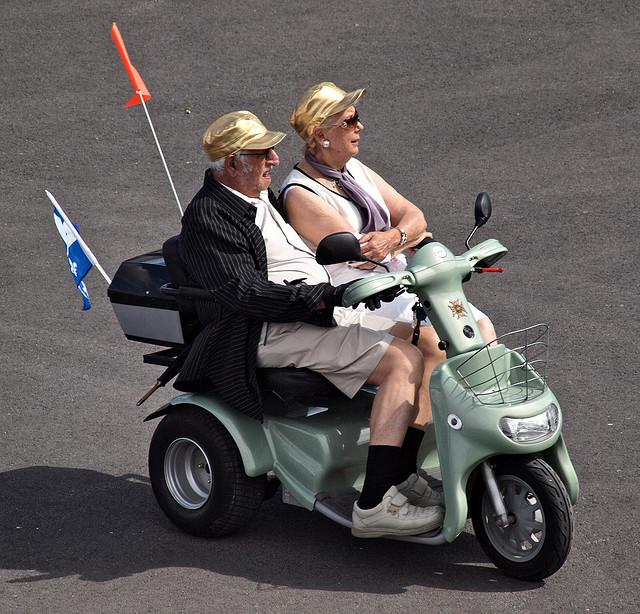Why are two of them on that little vehicle?

Choices:
A) lacking vehicles
B) are fighting
C) are hiding
D) economical transportation economical transportation 